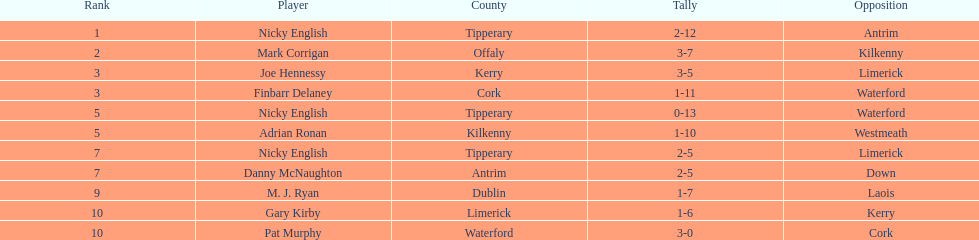What is the least total on the list? 9. 